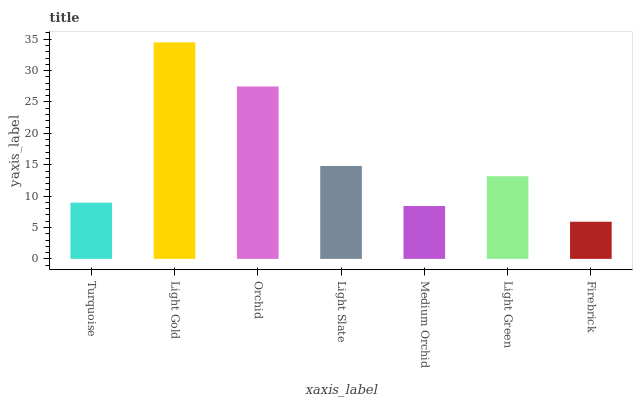Is Firebrick the minimum?
Answer yes or no. Yes. Is Light Gold the maximum?
Answer yes or no. Yes. Is Orchid the minimum?
Answer yes or no. No. Is Orchid the maximum?
Answer yes or no. No. Is Light Gold greater than Orchid?
Answer yes or no. Yes. Is Orchid less than Light Gold?
Answer yes or no. Yes. Is Orchid greater than Light Gold?
Answer yes or no. No. Is Light Gold less than Orchid?
Answer yes or no. No. Is Light Green the high median?
Answer yes or no. Yes. Is Light Green the low median?
Answer yes or no. Yes. Is Light Slate the high median?
Answer yes or no. No. Is Medium Orchid the low median?
Answer yes or no. No. 